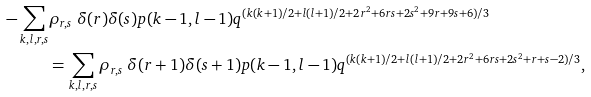<formula> <loc_0><loc_0><loc_500><loc_500>- \sum _ { k , l , r , s } & \rho _ { r , s } \ \delta ( r ) \delta ( s ) p ( k - 1 , l - 1 ) q ^ { ( k ( k + 1 ) / 2 + l ( l + 1 ) / 2 + 2 r ^ { 2 } + 6 r s + 2 s ^ { 2 } + 9 r + 9 s + 6 ) / 3 } \\ & = \sum _ { k , l , r , s } \rho _ { r , s } \ \delta ( r + 1 ) \delta ( s + 1 ) p ( k - 1 , l - 1 ) q ^ { ( k ( k + 1 ) / 2 + l ( l + 1 ) / 2 + 2 r ^ { 2 } + 6 r s + 2 s ^ { 2 } + r + s - 2 ) / 3 } ,</formula> 